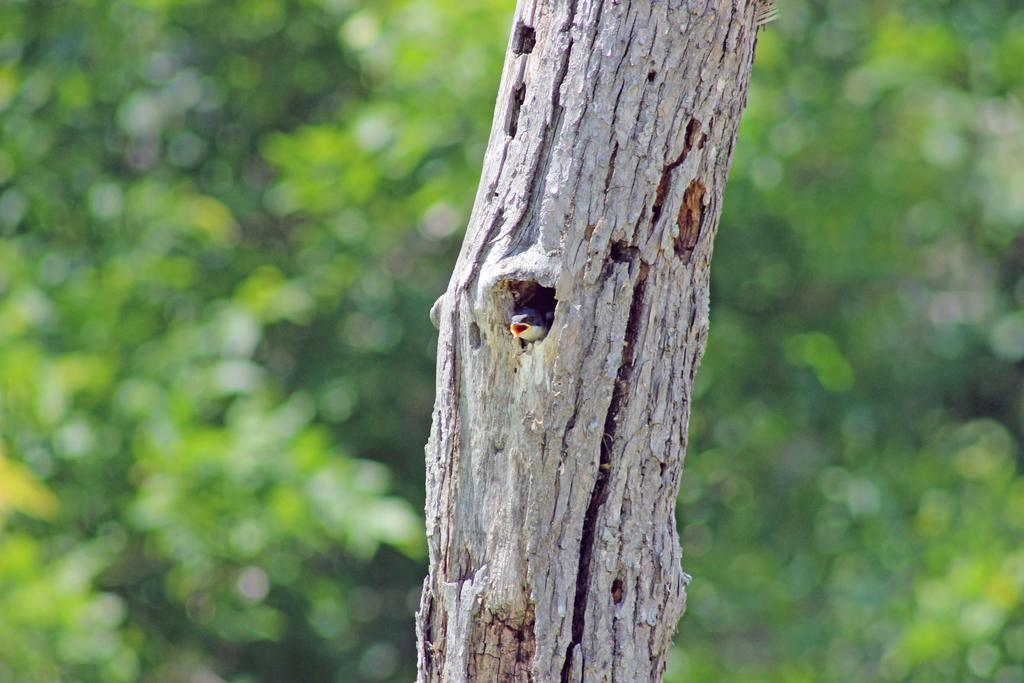What is the main subject of the image? The main subject of the image is a bird in a wooden trunk. What can be seen in the background of the image? There are plants in the background of the image. What is the representative of the bird's profit in the image? There is no mention of profit or representation in the image; it simply features a bird in a wooden trunk and plants in the background. 